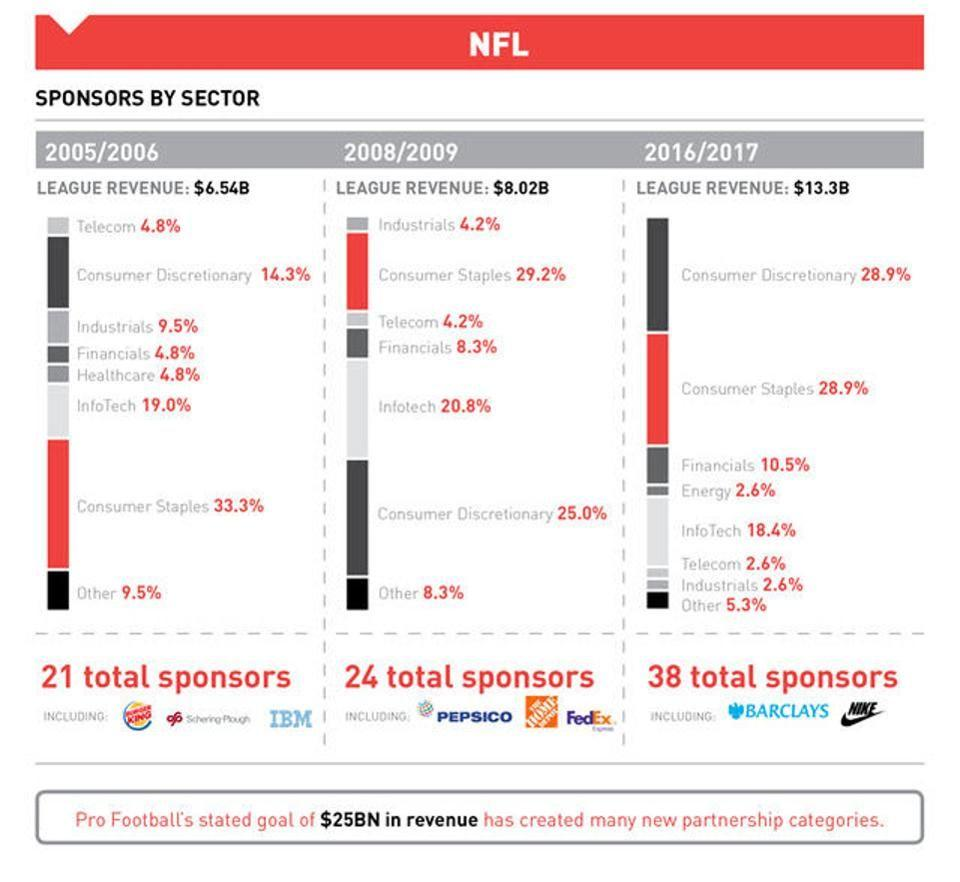List a handful of essential elements in this visual. In the year 2016/2017, sponsorship from the financial sector accounted for 10.5% of the total sponsorship received. In 2005/2006, there were 21 total sponsors. In the year of sponsorship from the Infotech sector, the percentage was 20.8%. This occurred during either 2008 or 2009. There were 24 total sponsors in 2008/2009. PepsiCo was confirmed as a sponsor during the years 2008/2009. 